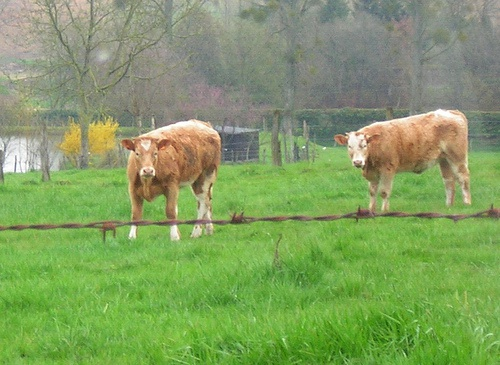Describe the objects in this image and their specific colors. I can see cow in darkgray, tan, and gray tones and cow in darkgray, gray, tan, and brown tones in this image. 